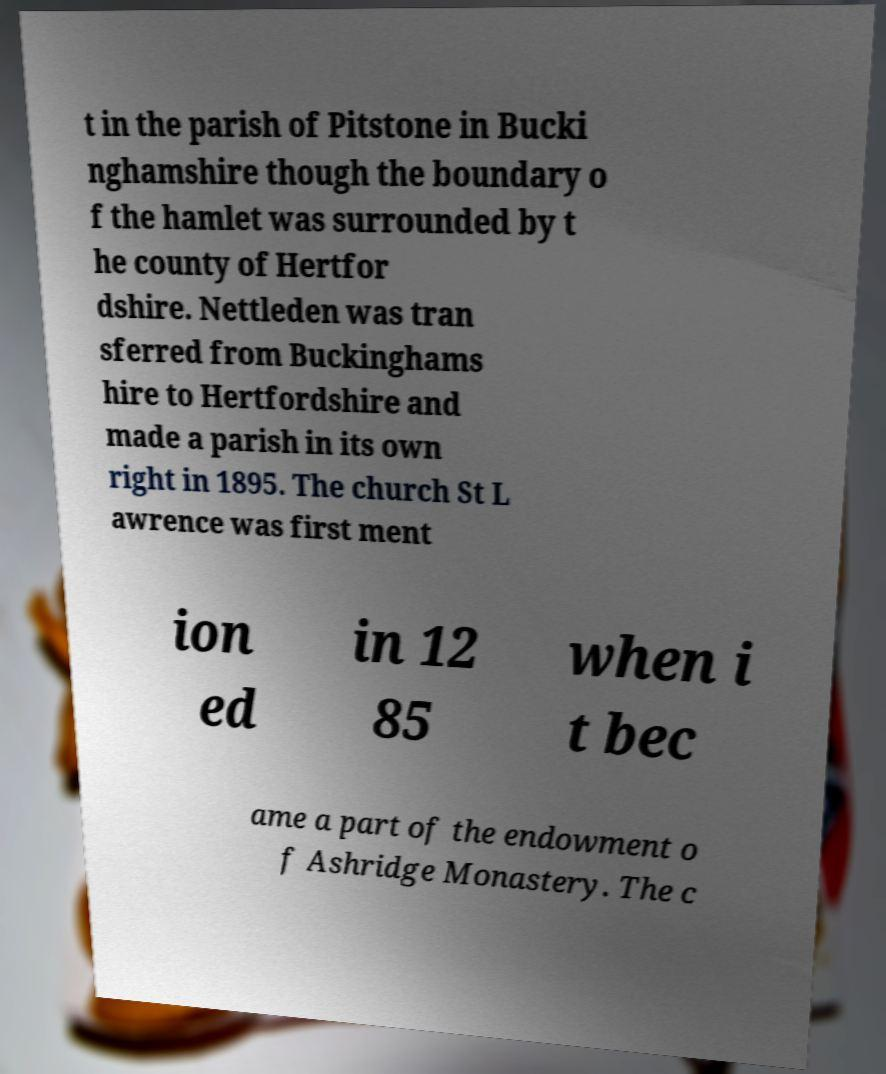Can you read and provide the text displayed in the image?This photo seems to have some interesting text. Can you extract and type it out for me? t in the parish of Pitstone in Bucki nghamshire though the boundary o f the hamlet was surrounded by t he county of Hertfor dshire. Nettleden was tran sferred from Buckinghams hire to Hertfordshire and made a parish in its own right in 1895. The church St L awrence was first ment ion ed in 12 85 when i t bec ame a part of the endowment o f Ashridge Monastery. The c 